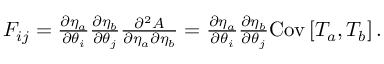<formula> <loc_0><loc_0><loc_500><loc_500>\begin{array} { r } { F _ { i j } = \frac { \partial \eta _ { a } } { \partial \theta _ { i } } \frac { \partial \eta _ { b } } { \partial \theta _ { j } } \frac { \partial ^ { 2 } A } { \partial \eta _ { a } \partial \eta _ { b } } = \frac { \partial \eta _ { a } } { \partial \theta _ { i } } \frac { \partial \eta _ { b } } { \partial \theta _ { j } } C o v \left [ T _ { a } , T _ { b } \right ] . } \end{array}</formula> 